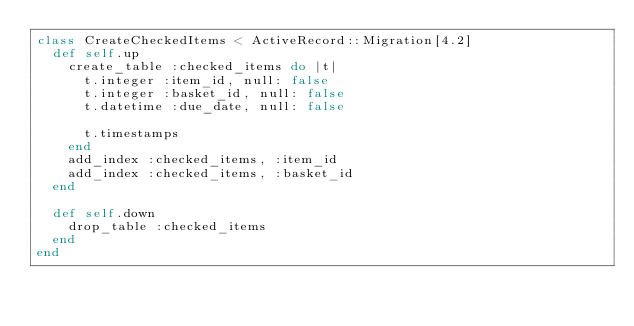Convert code to text. <code><loc_0><loc_0><loc_500><loc_500><_Ruby_>class CreateCheckedItems < ActiveRecord::Migration[4.2]
  def self.up
    create_table :checked_items do |t|
      t.integer :item_id, null: false
      t.integer :basket_id, null: false
      t.datetime :due_date, null: false

      t.timestamps
    end
    add_index :checked_items, :item_id
    add_index :checked_items, :basket_id
  end

  def self.down
    drop_table :checked_items
  end
end
</code> 